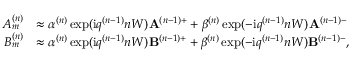Convert formula to latex. <formula><loc_0><loc_0><loc_500><loc_500>\begin{array} { r l } { A _ { m } ^ { ( n ) } } & { \approx \alpha ^ { ( n ) } \exp ( i q ^ { ( n - 1 ) } n W ) A ^ { ( n - 1 ) + } + \beta ^ { ( n ) } \exp ( - i q ^ { ( n - 1 ) } n W ) A ^ { ( n - 1 ) - } } \\ { B _ { m } ^ { ( n ) } } & { \approx \alpha ^ { ( n ) } \exp ( i q ^ { ( n - 1 ) } n W ) B ^ { ( n - 1 ) + } + \beta ^ { ( n ) } \exp ( - i q ^ { ( n - 1 ) } n W ) B ^ { ( n - 1 ) - } , } \end{array}</formula> 